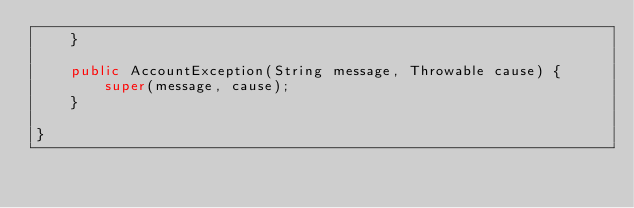<code> <loc_0><loc_0><loc_500><loc_500><_Java_>    }

    public AccountException(String message, Throwable cause) {
        super(message, cause);
    }

}
</code> 